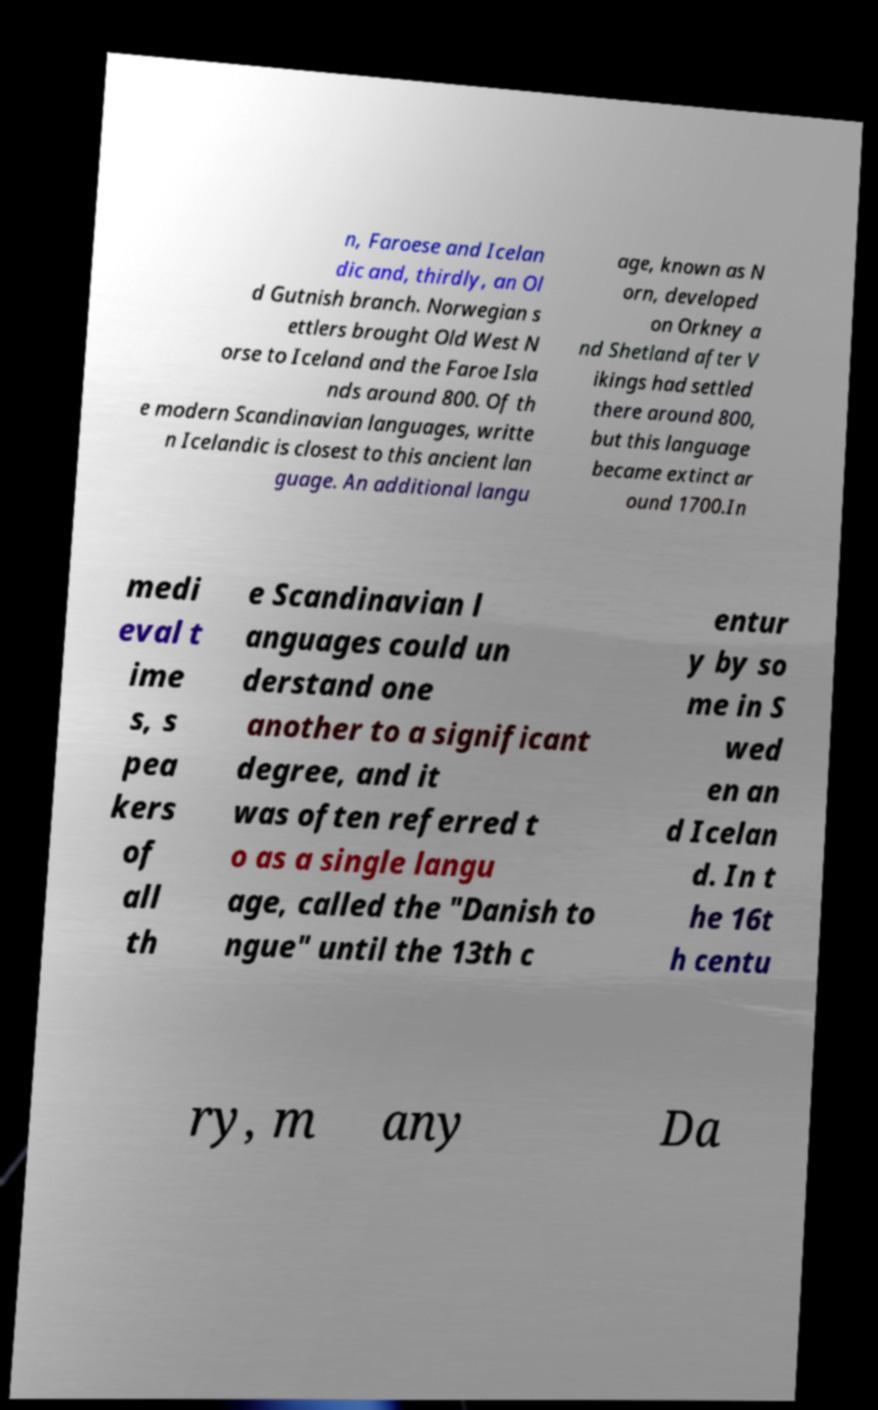Please identify and transcribe the text found in this image. n, Faroese and Icelan dic and, thirdly, an Ol d Gutnish branch. Norwegian s ettlers brought Old West N orse to Iceland and the Faroe Isla nds around 800. Of th e modern Scandinavian languages, writte n Icelandic is closest to this ancient lan guage. An additional langu age, known as N orn, developed on Orkney a nd Shetland after V ikings had settled there around 800, but this language became extinct ar ound 1700.In medi eval t ime s, s pea kers of all th e Scandinavian l anguages could un derstand one another to a significant degree, and it was often referred t o as a single langu age, called the "Danish to ngue" until the 13th c entur y by so me in S wed en an d Icelan d. In t he 16t h centu ry, m any Da 